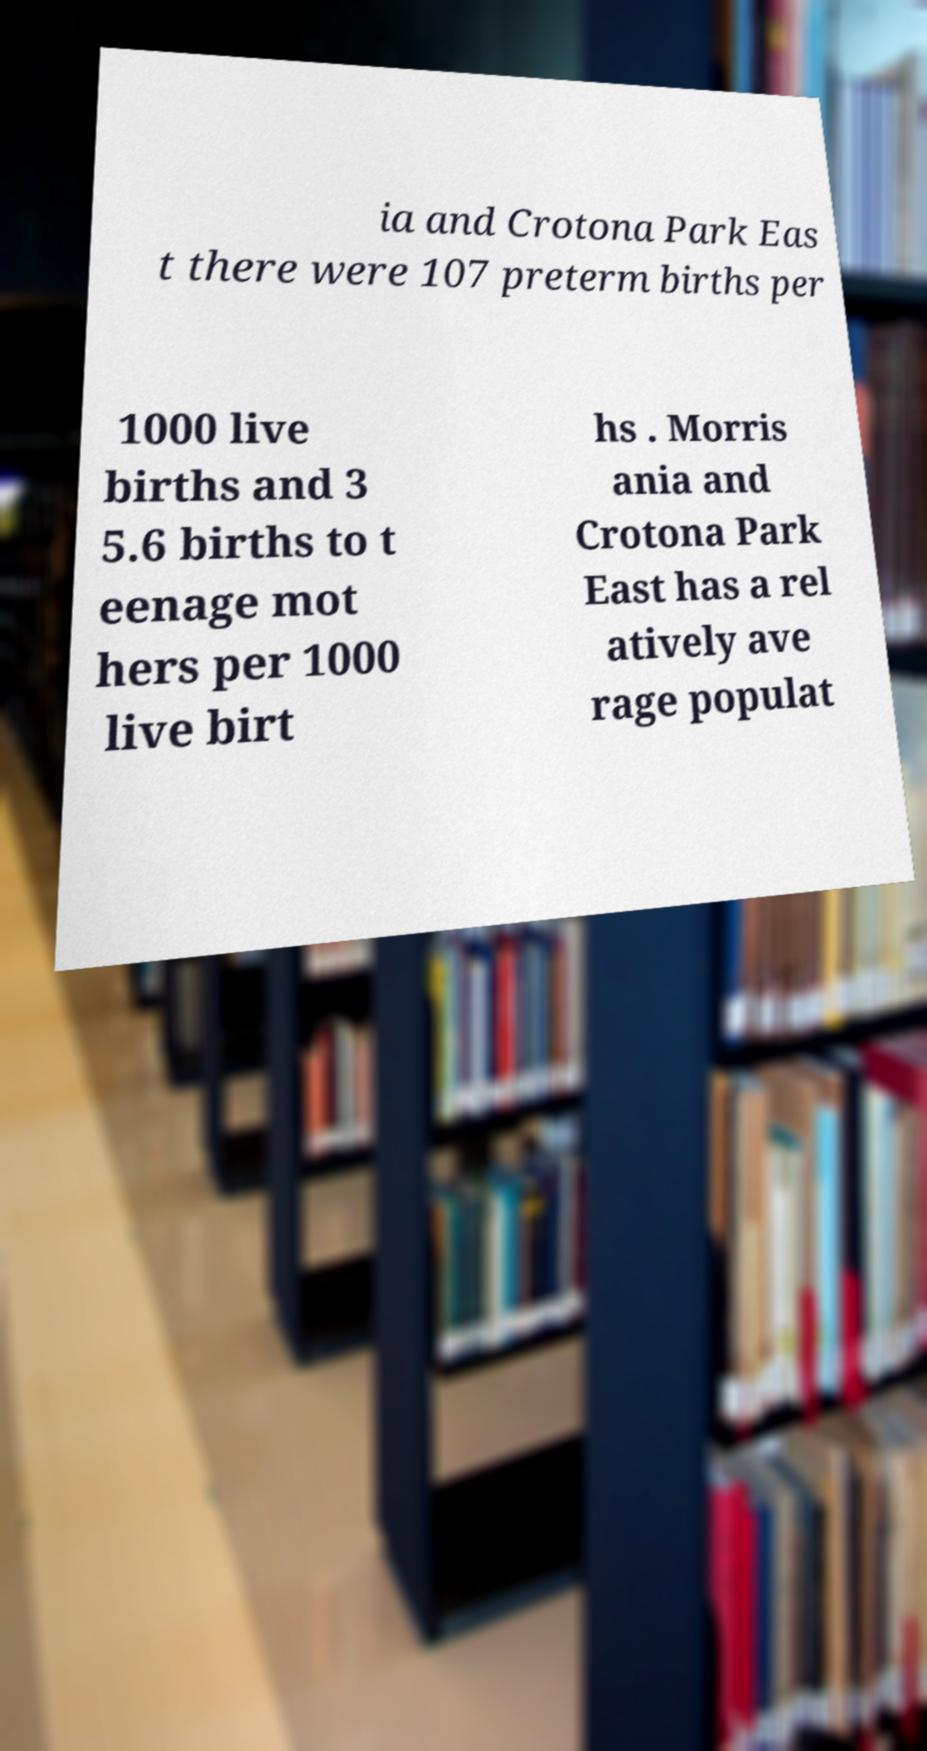Could you assist in decoding the text presented in this image and type it out clearly? ia and Crotona Park Eas t there were 107 preterm births per 1000 live births and 3 5.6 births to t eenage mot hers per 1000 live birt hs . Morris ania and Crotona Park East has a rel atively ave rage populat 